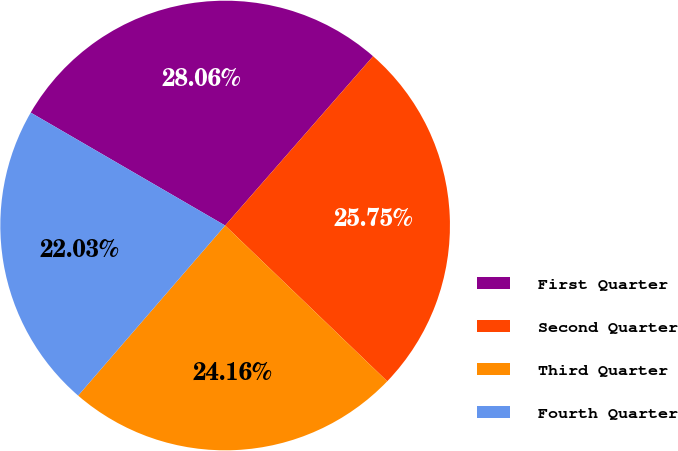<chart> <loc_0><loc_0><loc_500><loc_500><pie_chart><fcel>First Quarter<fcel>Second Quarter<fcel>Third Quarter<fcel>Fourth Quarter<nl><fcel>28.06%<fcel>25.75%<fcel>24.16%<fcel>22.03%<nl></chart> 